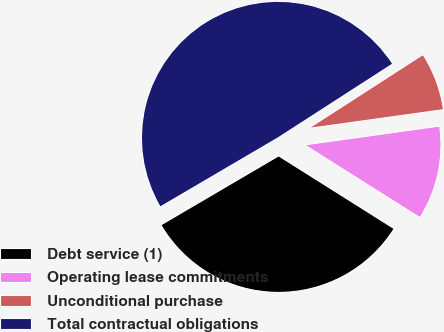<chart> <loc_0><loc_0><loc_500><loc_500><pie_chart><fcel>Debt service (1)<fcel>Operating lease commitments<fcel>Unconditional purchase<fcel>Total contractual obligations<nl><fcel>32.61%<fcel>11.15%<fcel>6.91%<fcel>49.33%<nl></chart> 